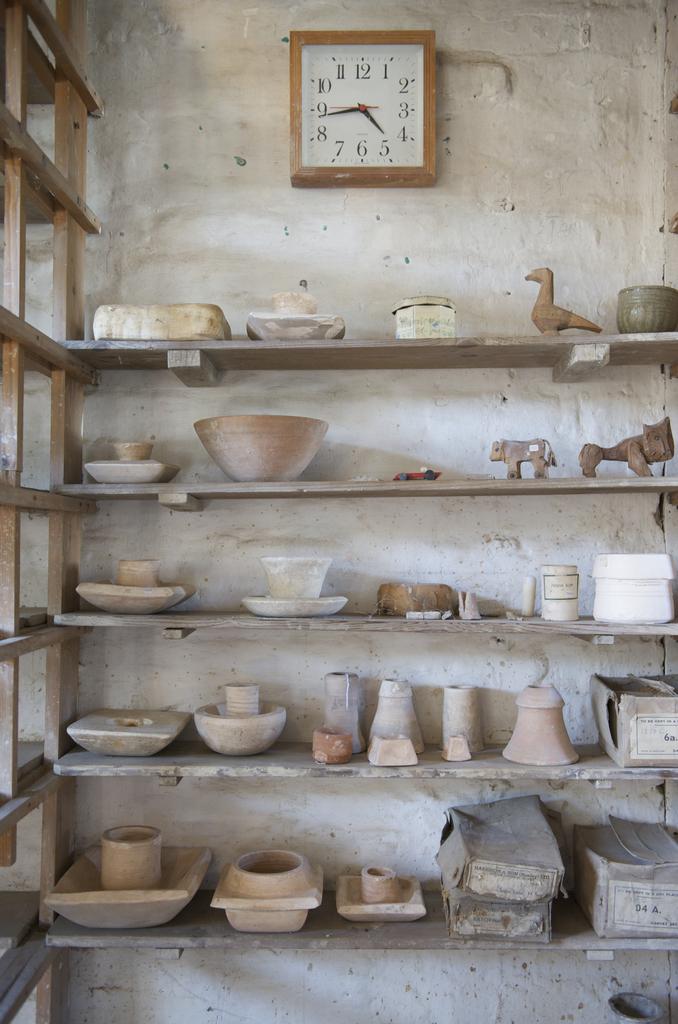What time does the clock say?
Your response must be concise. 4:44. What number is the little hand pointing towards?
Provide a short and direct response. 5. 